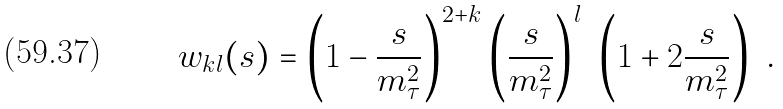<formula> <loc_0><loc_0><loc_500><loc_500>w _ { k l } ( s ) = \left ( 1 - \frac { s } { m _ { \tau } ^ { 2 } } \right ) ^ { 2 + k } \left ( \frac { s } { m _ { \tau } ^ { 2 } } \right ) ^ { l } \ \left ( 1 + 2 \frac { s } { m _ { \tau } ^ { 2 } } \right ) \ .</formula> 